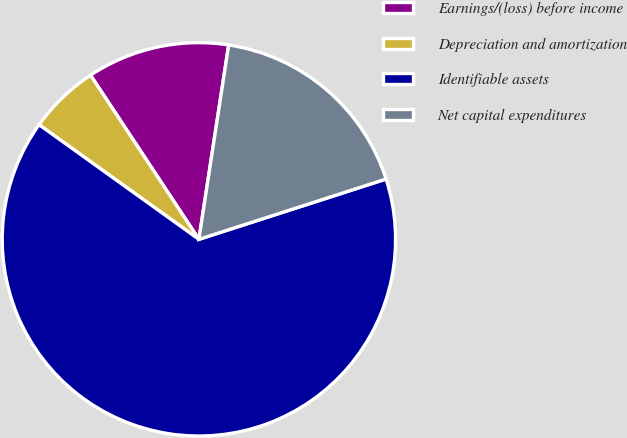Convert chart to OTSL. <chart><loc_0><loc_0><loc_500><loc_500><pie_chart><fcel>Earnings/(loss) before income<fcel>Depreciation and amortization<fcel>Identifiable assets<fcel>Net capital expenditures<nl><fcel>11.71%<fcel>5.81%<fcel>64.87%<fcel>17.62%<nl></chart> 